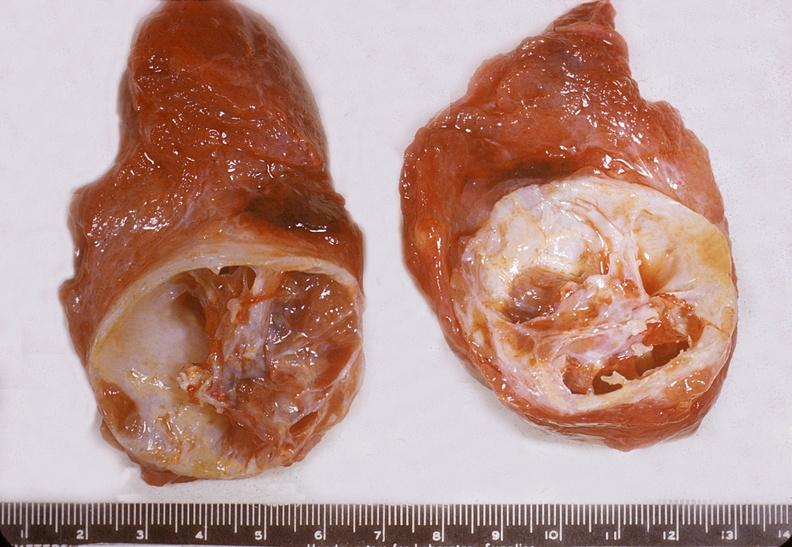what does this image show?
Answer the question using a single word or phrase. Thyroid 